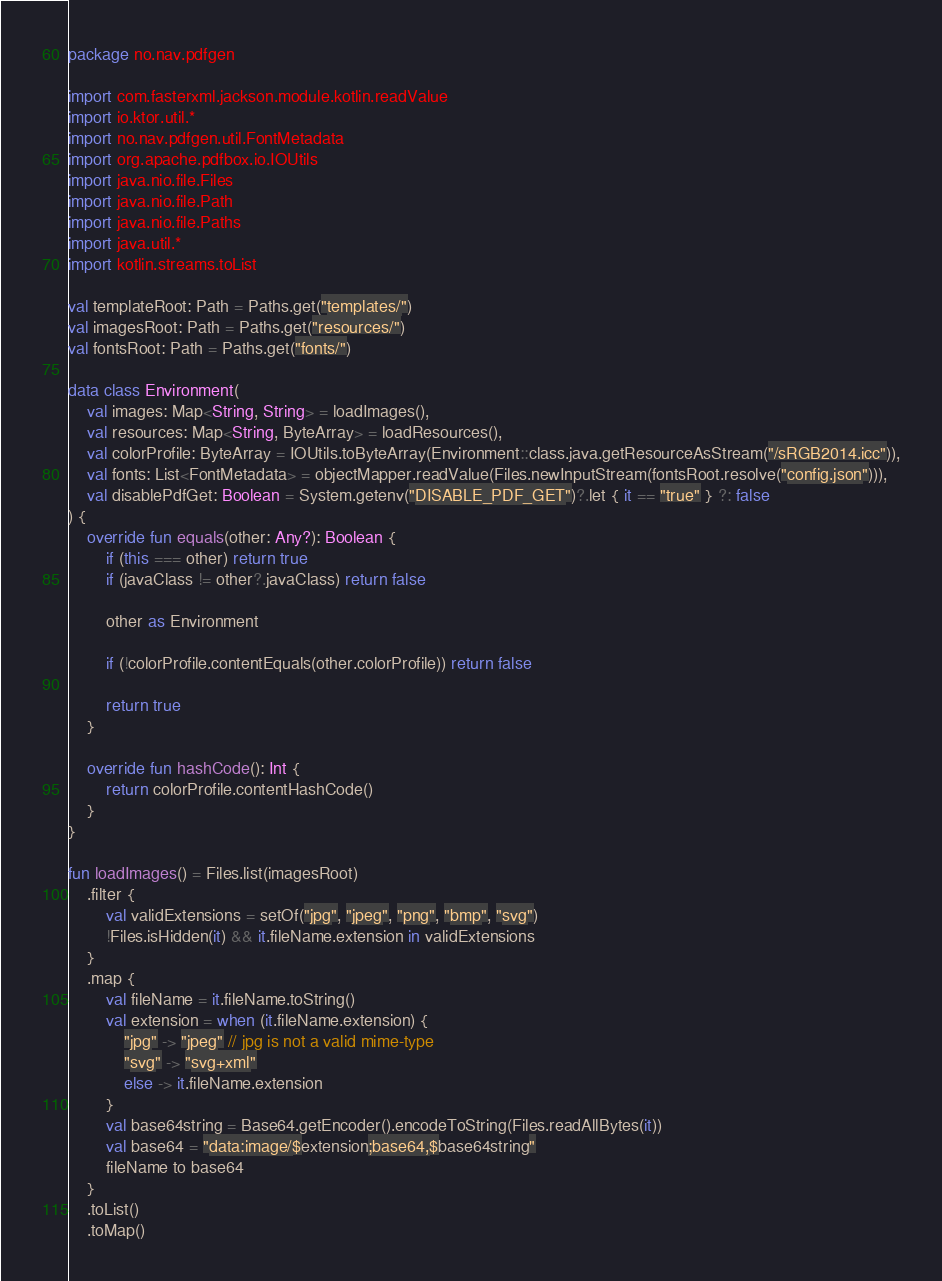<code> <loc_0><loc_0><loc_500><loc_500><_Kotlin_>package no.nav.pdfgen

import com.fasterxml.jackson.module.kotlin.readValue
import io.ktor.util.*
import no.nav.pdfgen.util.FontMetadata
import org.apache.pdfbox.io.IOUtils
import java.nio.file.Files
import java.nio.file.Path
import java.nio.file.Paths
import java.util.*
import kotlin.streams.toList

val templateRoot: Path = Paths.get("templates/")
val imagesRoot: Path = Paths.get("resources/")
val fontsRoot: Path = Paths.get("fonts/")

data class Environment(
    val images: Map<String, String> = loadImages(),
    val resources: Map<String, ByteArray> = loadResources(),
    val colorProfile: ByteArray = IOUtils.toByteArray(Environment::class.java.getResourceAsStream("/sRGB2014.icc")),
    val fonts: List<FontMetadata> = objectMapper.readValue(Files.newInputStream(fontsRoot.resolve("config.json"))),
    val disablePdfGet: Boolean = System.getenv("DISABLE_PDF_GET")?.let { it == "true" } ?: false
) {
    override fun equals(other: Any?): Boolean {
        if (this === other) return true
        if (javaClass != other?.javaClass) return false

        other as Environment

        if (!colorProfile.contentEquals(other.colorProfile)) return false

        return true
    }

    override fun hashCode(): Int {
        return colorProfile.contentHashCode()
    }
}

fun loadImages() = Files.list(imagesRoot)
    .filter {
        val validExtensions = setOf("jpg", "jpeg", "png", "bmp", "svg")
        !Files.isHidden(it) && it.fileName.extension in validExtensions
    }
    .map {
        val fileName = it.fileName.toString()
        val extension = when (it.fileName.extension) {
            "jpg" -> "jpeg" // jpg is not a valid mime-type
            "svg" -> "svg+xml"
            else -> it.fileName.extension
        }
        val base64string = Base64.getEncoder().encodeToString(Files.readAllBytes(it))
        val base64 = "data:image/$extension;base64,$base64string"
        fileName to base64
    }
    .toList()
    .toMap()
</code> 